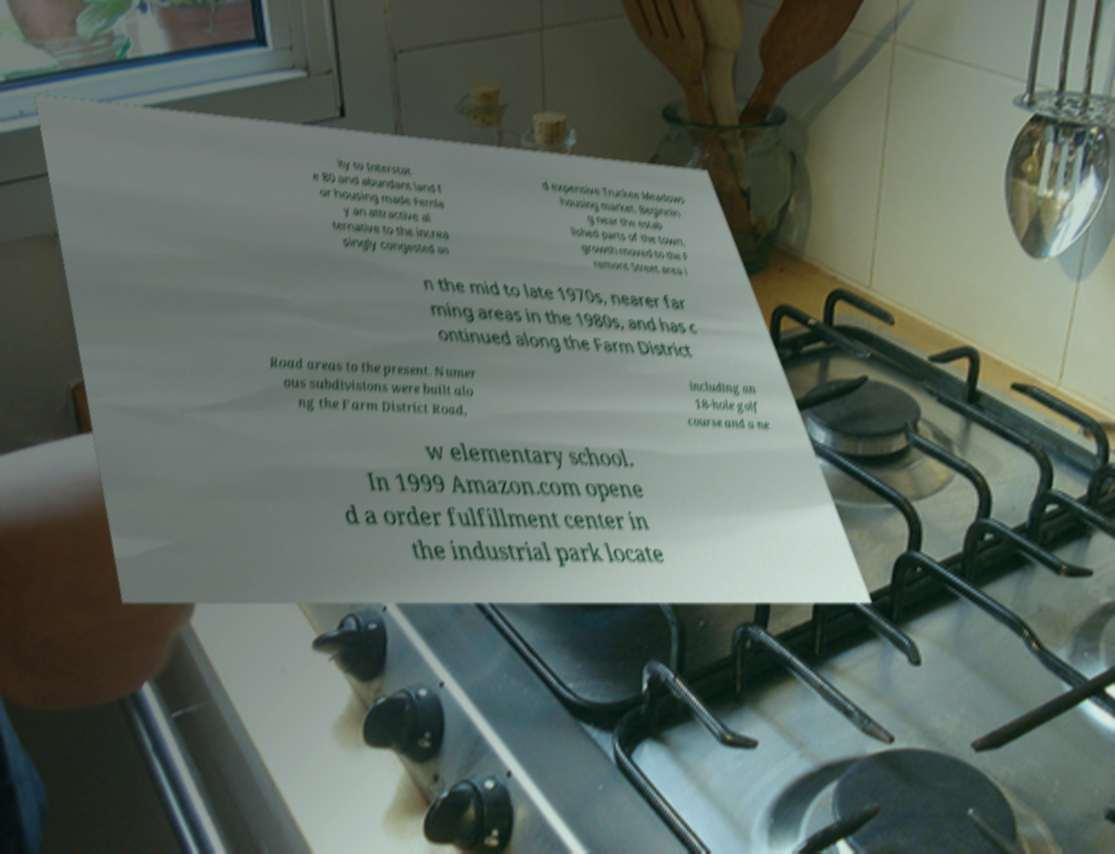What messages or text are displayed in this image? I need them in a readable, typed format. ity to Interstat e 80 and abundant land f or housing made Fernle y an attractive al ternative to the increa singly congested an d expensive Truckee Meadows housing market. Beginnin g near the estab lished parts of the town, growth moved to the F remont Street area i n the mid to late 1970s, nearer far ming areas in the 1980s, and has c ontinued along the Farm District Road areas to the present. Numer ous subdivisions were built alo ng the Farm District Road, including an 18-hole golf course and a ne w elementary school. In 1999 Amazon.com opene d a order fulfillment center in the industrial park locate 